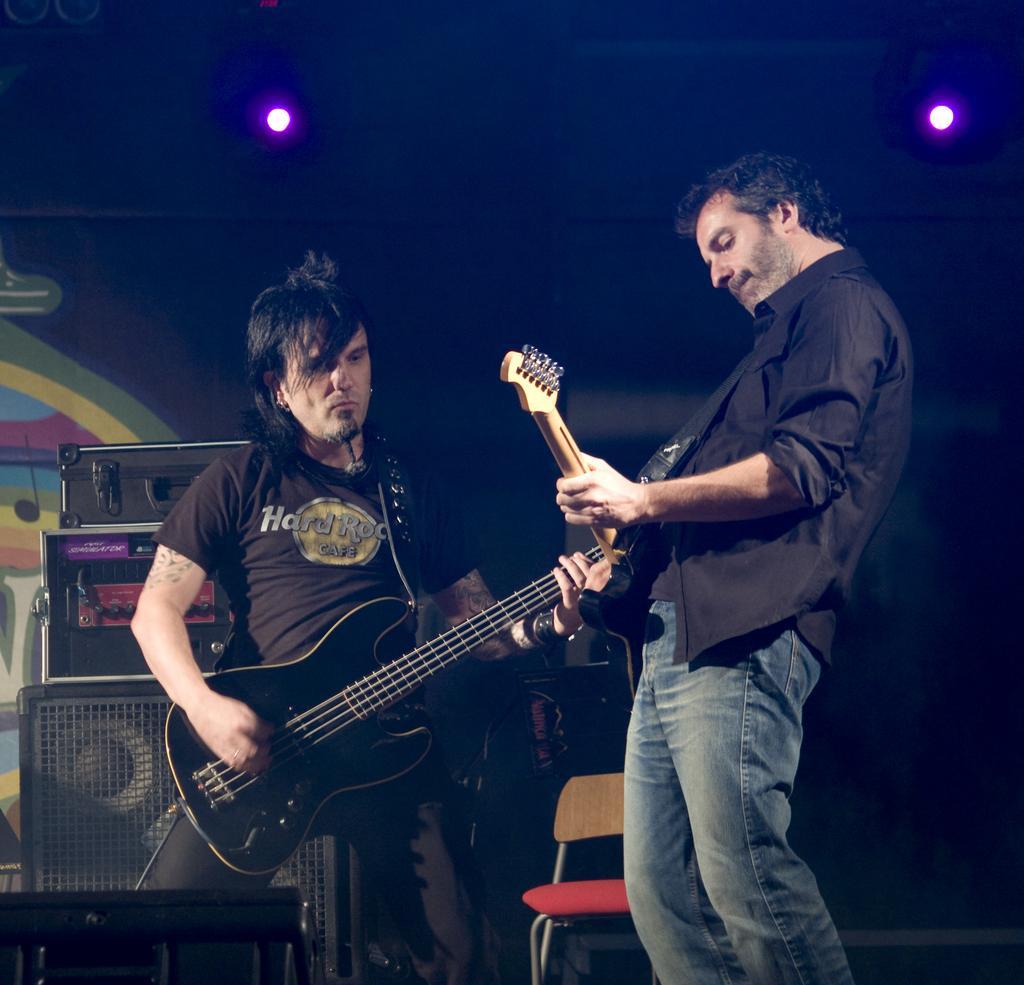Describe this image in one or two sentences. In this image there are two men they both are playing guitars. On the right there is a man he wear black shirt and trouser he is playing guitar. In the background there are speakers, chair and light. 